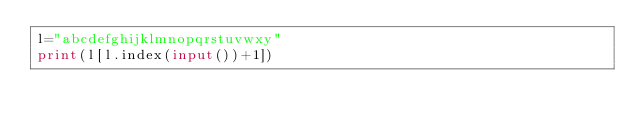<code> <loc_0><loc_0><loc_500><loc_500><_Python_>l="abcdefghijklmnopqrstuvwxy"
print(l[l.index(input())+1])</code> 